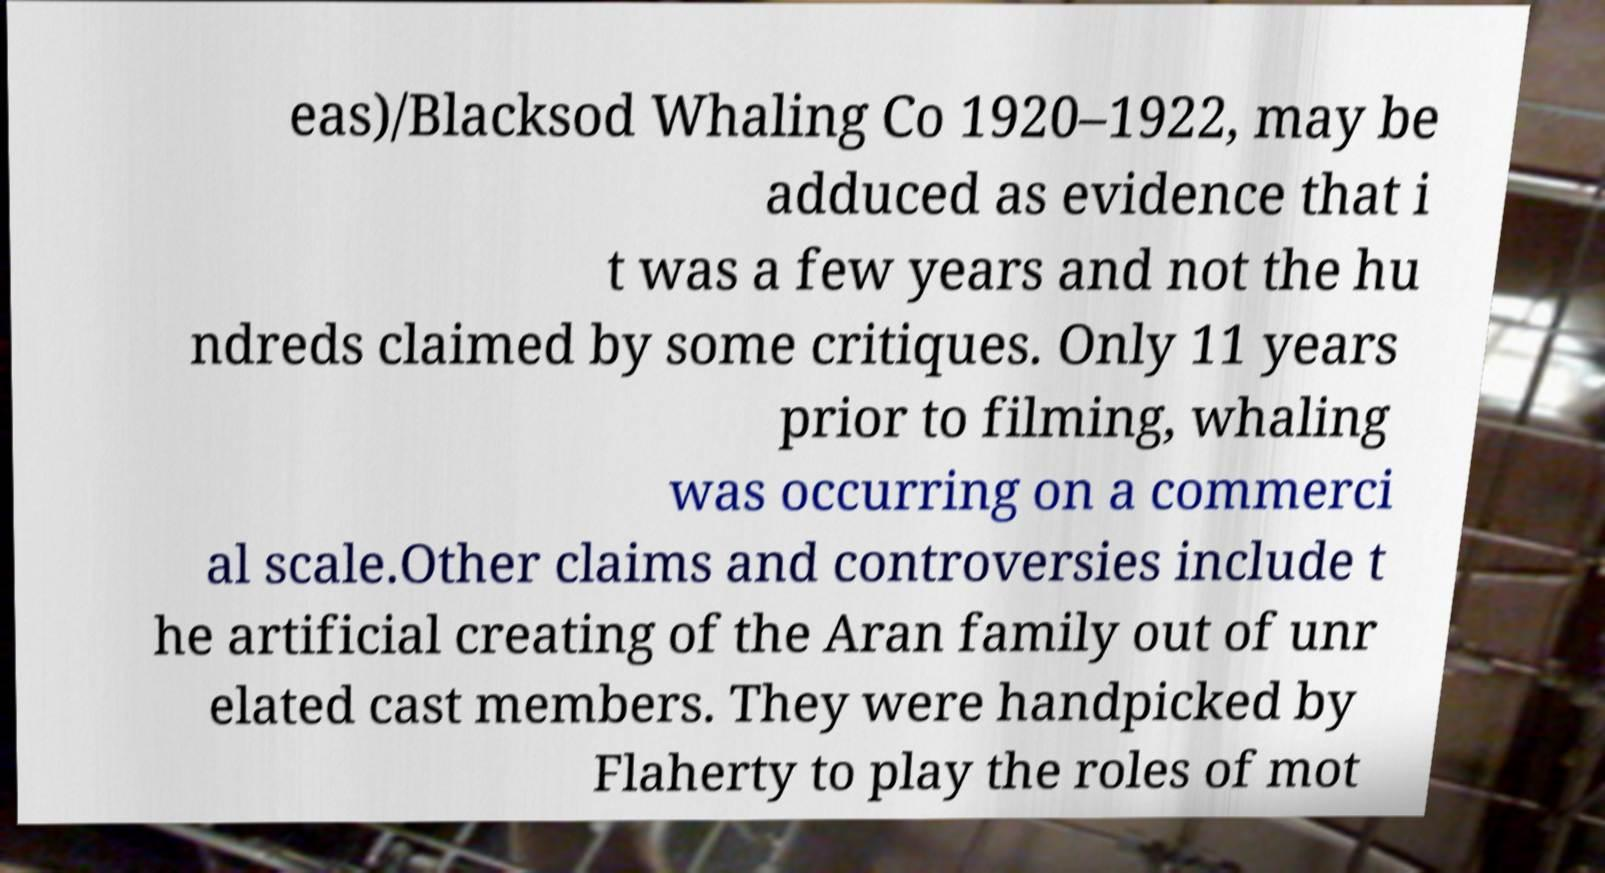Can you accurately transcribe the text from the provided image for me? eas)/Blacksod Whaling Co 1920–1922, may be adduced as evidence that i t was a few years and not the hu ndreds claimed by some critiques. Only 11 years prior to filming, whaling was occurring on a commerci al scale.Other claims and controversies include t he artificial creating of the Aran family out of unr elated cast members. They were handpicked by Flaherty to play the roles of mot 